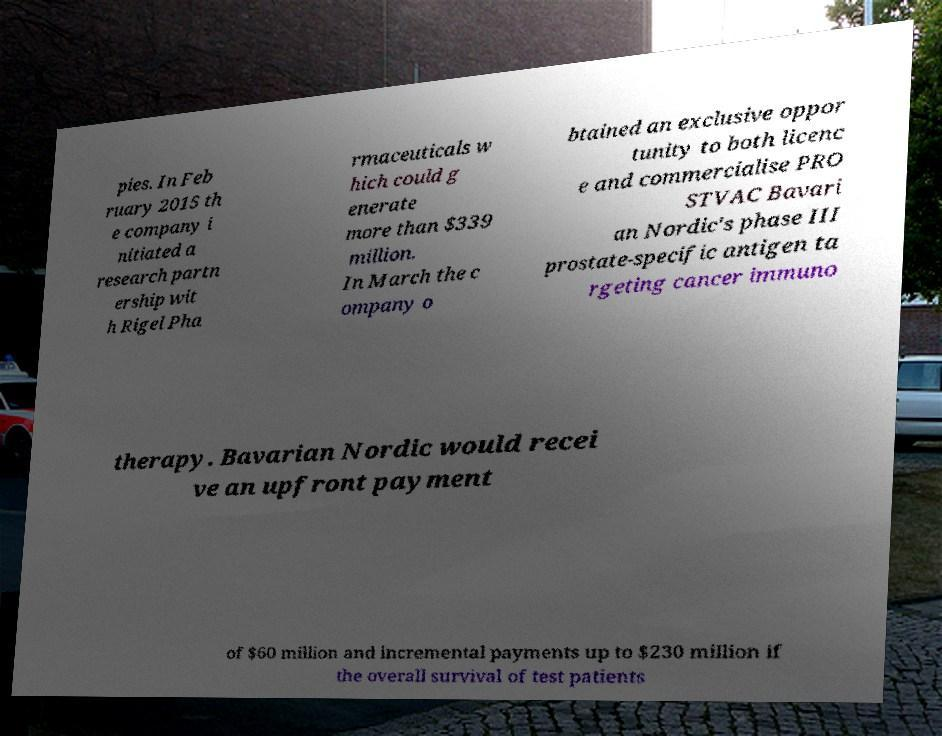Could you assist in decoding the text presented in this image and type it out clearly? pies. In Feb ruary 2015 th e company i nitiated a research partn ership wit h Rigel Pha rmaceuticals w hich could g enerate more than $339 million. In March the c ompany o btained an exclusive oppor tunity to both licenc e and commercialise PRO STVAC Bavari an Nordic's phase III prostate-specific antigen ta rgeting cancer immuno therapy. Bavarian Nordic would recei ve an upfront payment of $60 million and incremental payments up to $230 million if the overall survival of test patients 